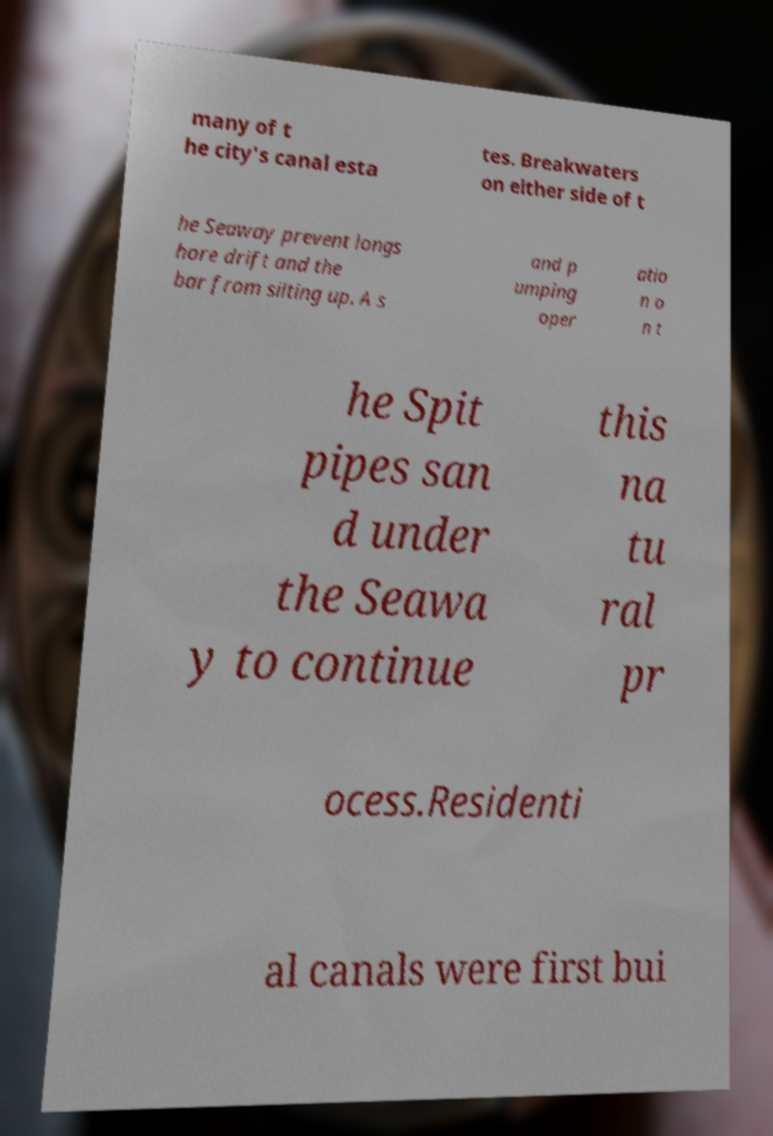What messages or text are displayed in this image? I need them in a readable, typed format. many of t he city's canal esta tes. Breakwaters on either side of t he Seaway prevent longs hore drift and the bar from silting up. A s and p umping oper atio n o n t he Spit pipes san d under the Seawa y to continue this na tu ral pr ocess.Residenti al canals were first bui 